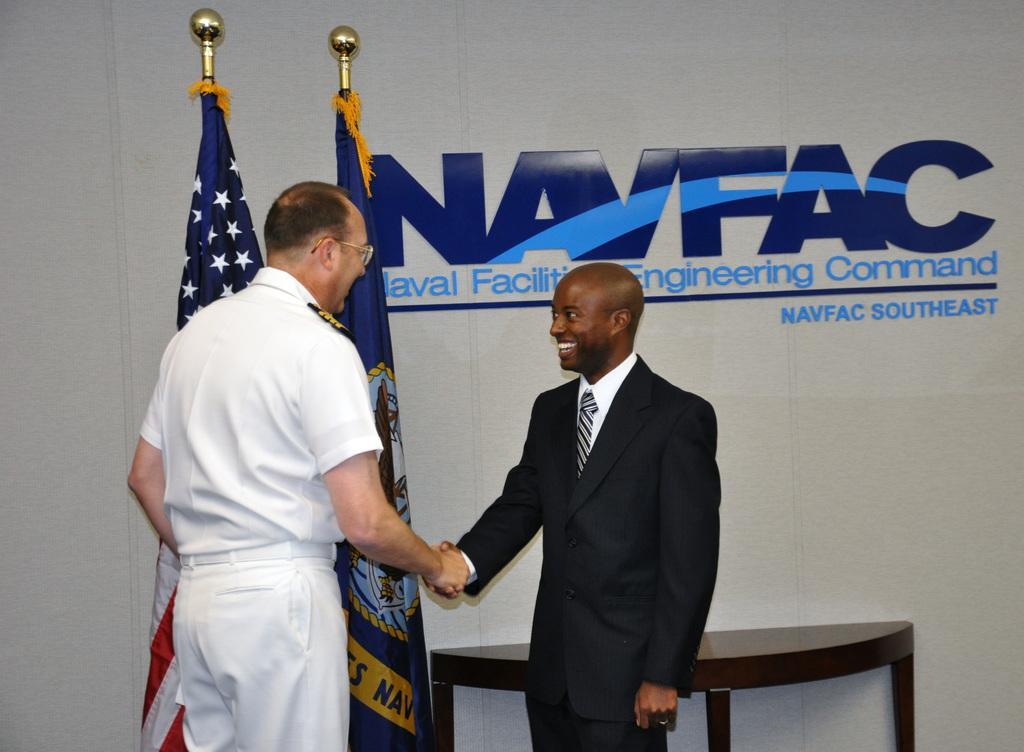Describe this image in one or two sentences. In this image we can see two persons. One person is wearing spectacles. One person is wearing a coat. In the background, we can see a table, two flags on poles and a wall with some text on it. 